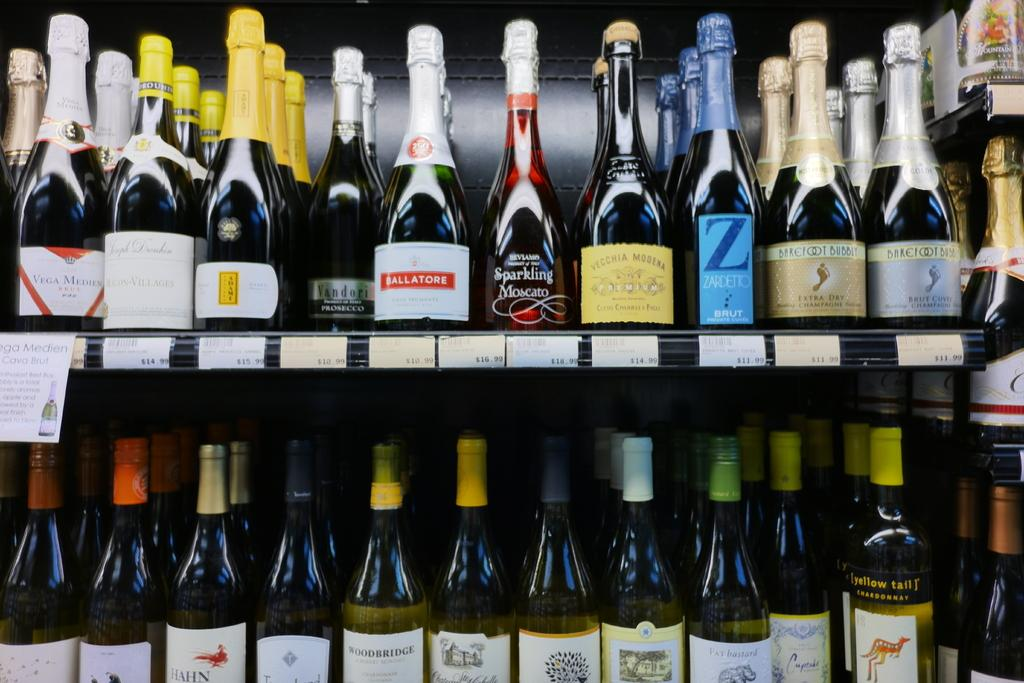Provide a one-sentence caption for the provided image. Store with a row selling alcohol including a bottle that says Z. 